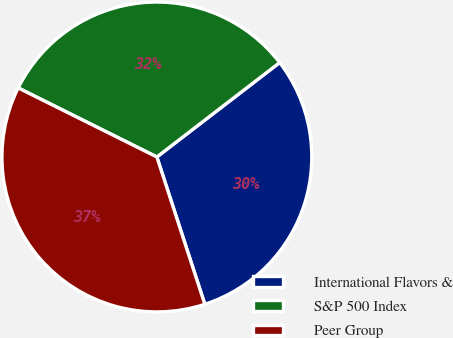Convert chart. <chart><loc_0><loc_0><loc_500><loc_500><pie_chart><fcel>International Flavors &<fcel>S&P 500 Index<fcel>Peer Group<nl><fcel>30.42%<fcel>32.21%<fcel>37.36%<nl></chart> 